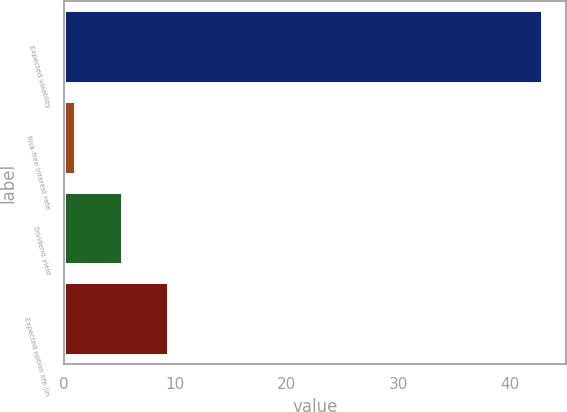Convert chart. <chart><loc_0><loc_0><loc_500><loc_500><bar_chart><fcel>Expected volatility<fcel>Risk-free interest rate<fcel>Dividend yield<fcel>Expected option life (in<nl><fcel>42.93<fcel>0.98<fcel>5.18<fcel>9.38<nl></chart> 